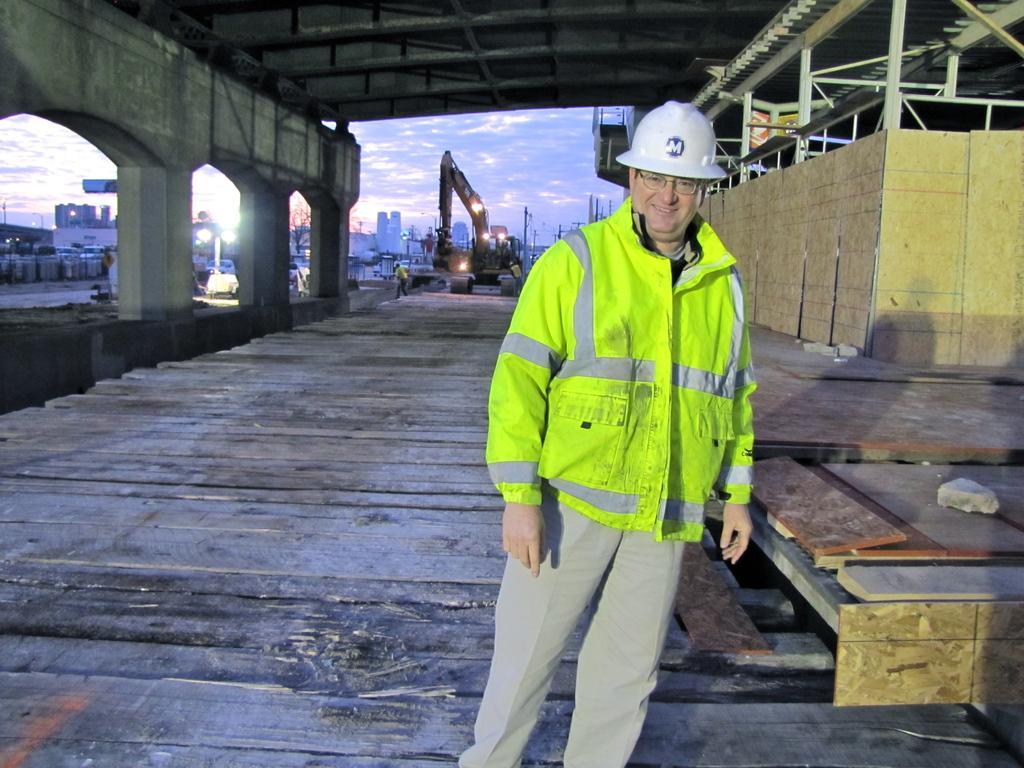How would you summarize this image in a sentence or two? In this picture I can see a man is standing. The man is wearing helmet, green color jacket and pant. In the background I can see vehicles, buildings, lights and the sky. Here I can see some pillars. 